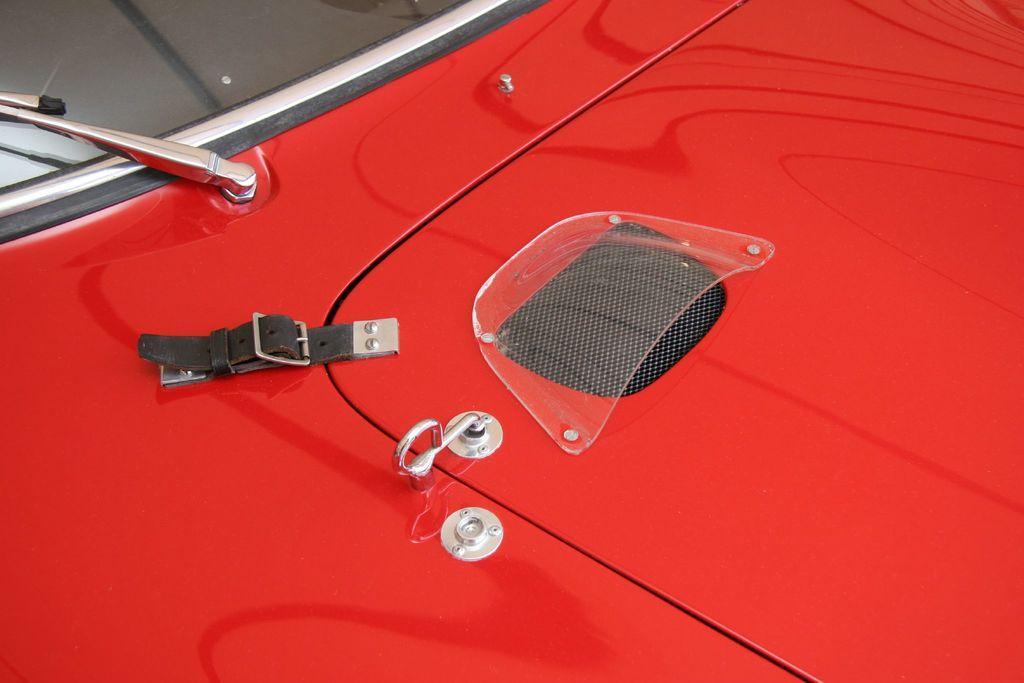Can you describe this image briefly? In the image we can see the front part of the vehicle. 